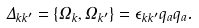<formula> <loc_0><loc_0><loc_500><loc_500>\Delta _ { k k ^ { \prime } } = \{ \Omega _ { k } , \Omega _ { k ^ { \prime } } \} = \epsilon _ { k k ^ { \prime } } q _ { a } q _ { a } .</formula> 